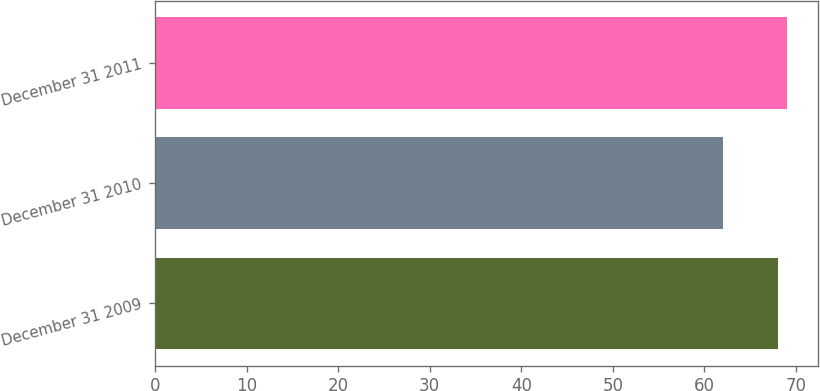Convert chart. <chart><loc_0><loc_0><loc_500><loc_500><bar_chart><fcel>December 31 2009<fcel>December 31 2010<fcel>December 31 2011<nl><fcel>68<fcel>62<fcel>69<nl></chart> 